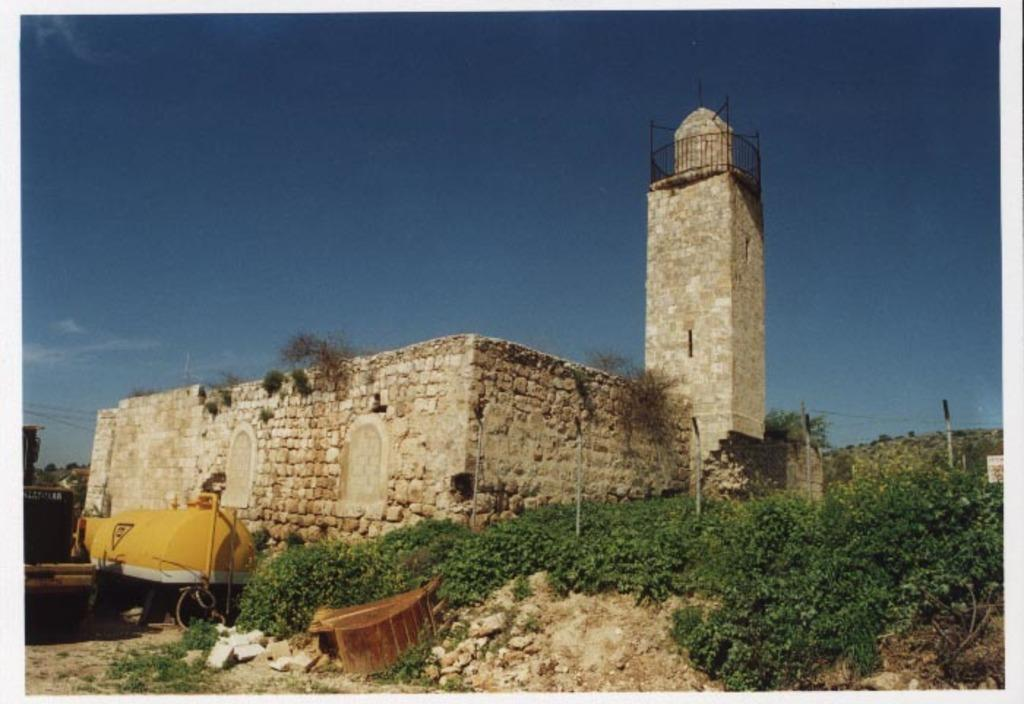What type of editing has been done to the image? The image is edited, but the specific type of editing is not mentioned in the facts. What type of structure can be seen in the image? There is a building and a tower in the image. What is present at the bottom of the image? There are plants, poles, and other objects at the bottom of the image. What can be seen in the background of the image? The sky is visible in the background of the image. What type of flower is being held by the actor in the image? There is no actor or flower present in the image. 